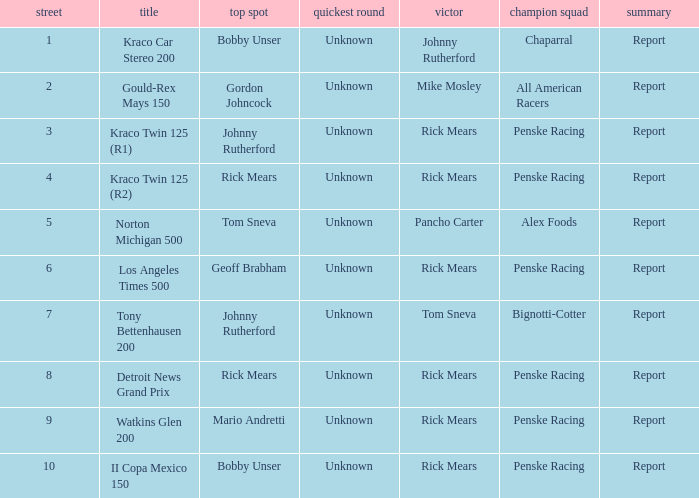What are the races that johnny rutherford has won? Kraco Car Stereo 200. 